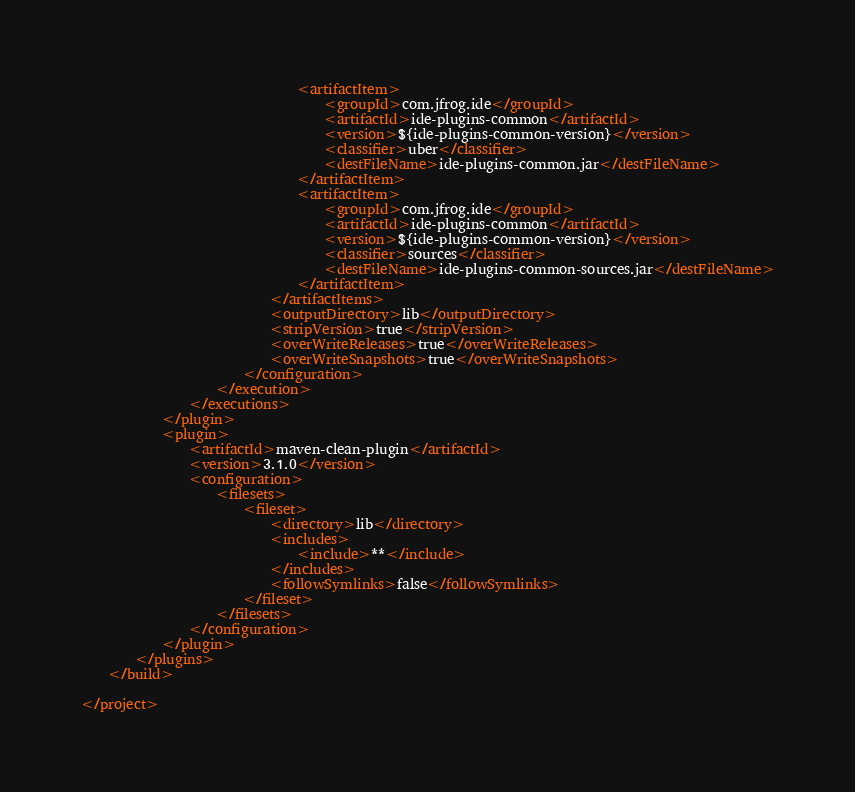<code> <loc_0><loc_0><loc_500><loc_500><_XML_>								<artifactItem>
									<groupId>com.jfrog.ide</groupId>
									<artifactId>ide-plugins-common</artifactId>
									<version>${ide-plugins-common-version}</version>
									<classifier>uber</classifier>
									<destFileName>ide-plugins-common.jar</destFileName>
								</artifactItem>
								<artifactItem>
									<groupId>com.jfrog.ide</groupId>
									<artifactId>ide-plugins-common</artifactId>
									<version>${ide-plugins-common-version}</version>
									<classifier>sources</classifier>
									<destFileName>ide-plugins-common-sources.jar</destFileName>
								</artifactItem>
							</artifactItems>
							<outputDirectory>lib</outputDirectory>
							<stripVersion>true</stripVersion>
							<overWriteReleases>true</overWriteReleases>
							<overWriteSnapshots>true</overWriteSnapshots>
						</configuration>
					</execution>
				</executions>
			</plugin>
			<plugin>
				<artifactId>maven-clean-plugin</artifactId>
				<version>3.1.0</version>
				<configuration>
					<filesets>
						<fileset>
							<directory>lib</directory>
							<includes>
								<include>**</include>
							</includes>
							<followSymlinks>false</followSymlinks>
						</fileset>
					</filesets>
				</configuration>
			</plugin>
		</plugins>
	</build>

</project>
</code> 